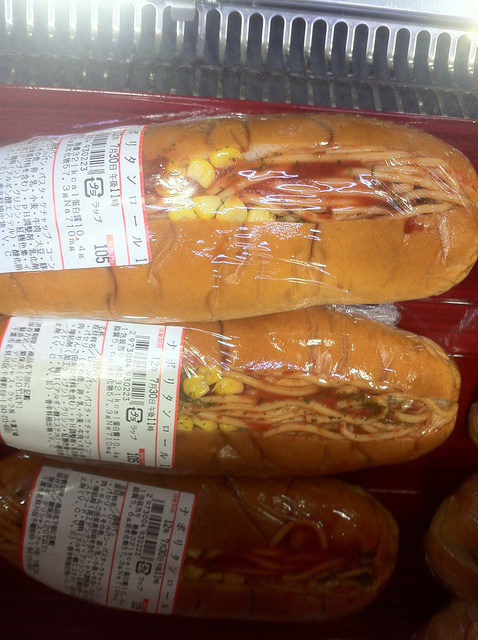Read all the text in this image. 5 105 